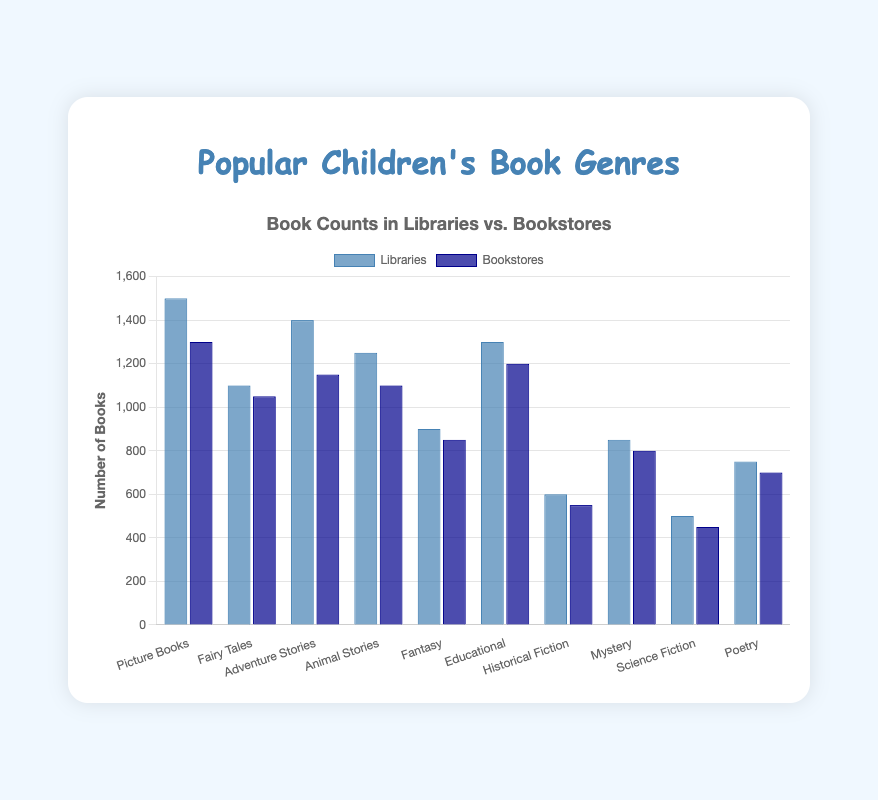Which genre has the highest number of books in libraries and what is that number? To determine the genre with the highest number of books in libraries, look at the bar representing library counts and identify the tallest bar. The tallest bar is for "Picture Books" with a count of 1500.
Answer: Picture Books, 1500 Which genre has the smallest difference in book counts between libraries and bookstores? Calculate the differences between library and bookstore counts for each genre: Picture Books (200), Fairy Tales (50), Adventure Stories (250), Animal Stories (150), Fantasy (50), Educational (100), Historical Fiction (50), Mystery (50), Science Fiction (50), and Poetry (50). The smallest difference is 50 and applies to multiple genres.
Answer: Fairy Tales, Fantasy, Historical Fiction, Mystery, Science Fiction, Poetry (50) What is the total number of books in bookstores across all genres? Add the bookstore counts for all genres: 1300 + 1050 + 1150 + 1100 + 850 + 1200 + 550 + 800 + 450 + 700 = 9150.
Answer: 9150 Which genre has more books in bookstores than in libraries? Compare the bookstore and library counts for each genre: all genres have fewer books in bookstores than in libraries. Therefore, none of the genres have more books in bookstores than in libraries.
Answer: None How many more Adventure Stories are there in libraries compared to bookstores? Subtract the number of Adventure Stories in bookstores from the number of Adventure Stories in libraries: 1400 - 1150 = 250.
Answer: 250 Which genres have equal number of books in libraries and bookstores? Compare each genre's library and bookstore counts: none of the genres have the exact same number of books in both libraries and bookstores.
Answer: None What is the average number of books in libraries across all genres? Add all library counts and then divide by the number of genres: (1500 + 1100 + 1400 + 1250 + 900 + 1300 + 600 + 850 + 500 + 750) / 10 = 10150 / 10 = 1015.
Answer: 1015 Which genre represents the largest group in bookstores after Picture Books? Identify the genre with the highest count in bookstores, then find the next highest count: Fair Tales (1050), Adventure Stories (1150), Animal Stories (1100), Fantasy (850), Educational (1200), Historical Fiction (550), Mystery (800), Science Fiction (450), Poetry (700). "Educational" has the next highest count after "Picture Books".
Answer: Educational 